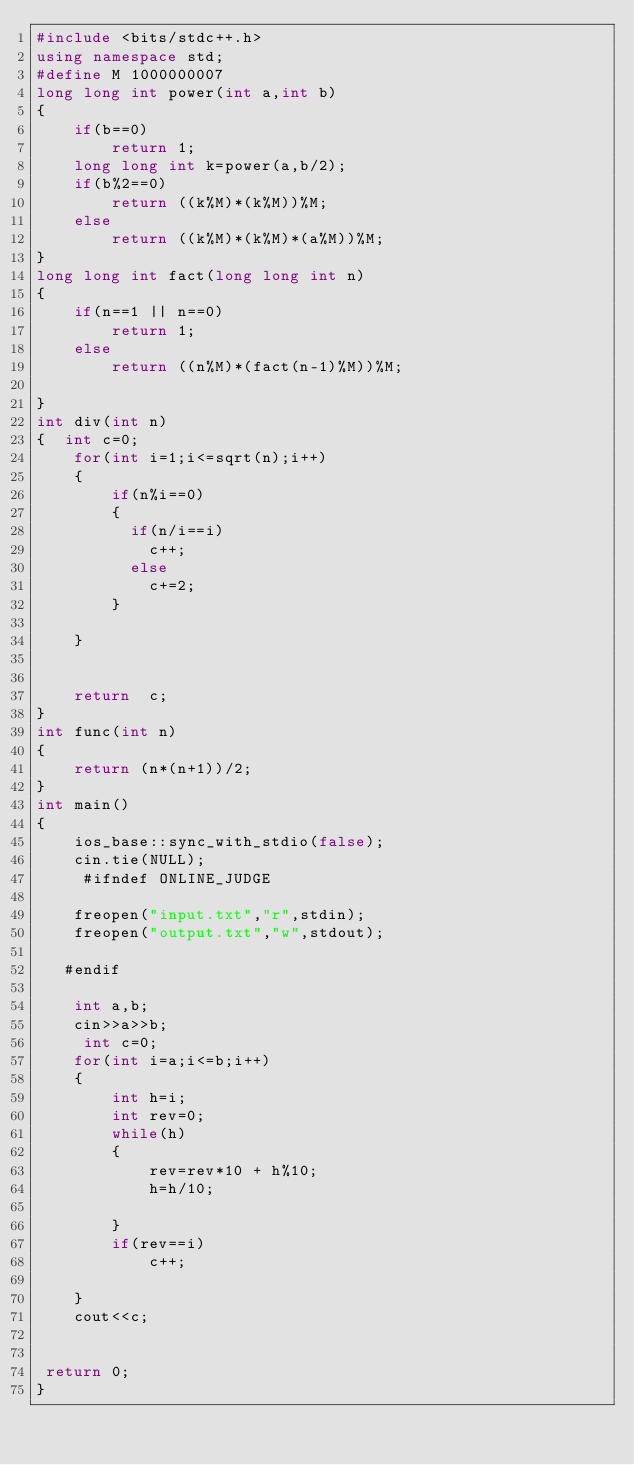<code> <loc_0><loc_0><loc_500><loc_500><_C++_>#include <bits/stdc++.h>
using namespace std;
#define M 1000000007
long long int power(int a,int b)
{
    if(b==0)
        return 1;
    long long int k=power(a,b/2);
    if(b%2==0)
        return ((k%M)*(k%M))%M;
    else
        return ((k%M)*(k%M)*(a%M))%M;
}
long long int fact(long long int n)
{
    if(n==1 || n==0)
        return 1;
    else
        return ((n%M)*(fact(n-1)%M))%M;

}
int div(int n)
{  int c=0;
    for(int i=1;i<=sqrt(n);i++)
    {
        if(n%i==0)
        {
          if(n/i==i)
            c++;
          else
            c+=2;
        }

    }

    
    return  c;
}
int func(int n)
{
    return (n*(n+1))/2;
}
int main()
{
    ios_base::sync_with_stdio(false);
    cin.tie(NULL);
     #ifndef ONLINE_JUDGE
 
    freopen("input.txt","r",stdin);
    freopen("output.txt","w",stdout);
 
   #endif
   
    int a,b;
    cin>>a>>b;
     int c=0;
    for(int i=a;i<=b;i++)
    {
        int h=i;
        int rev=0;
        while(h)
        {
            rev=rev*10 + h%10;
            h=h/10;

        }
        if(rev==i)
            c++;

    }
    cout<<c;


 return 0;
}






</code> 